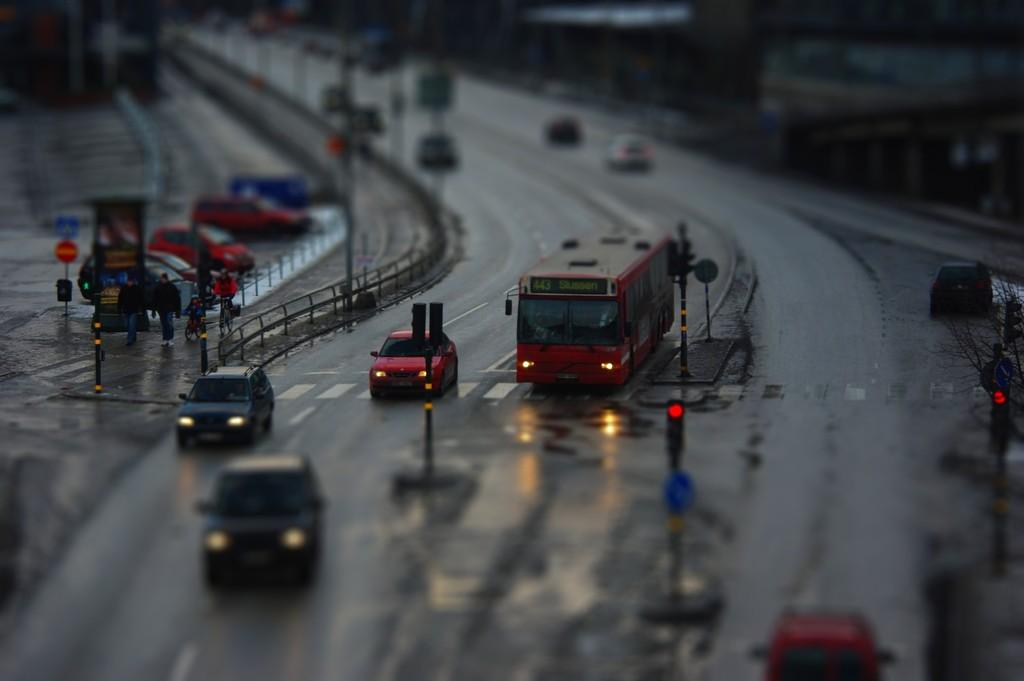What is the overall quality of the image? The image is partially blurred. What can be seen on the road in the image? There are vehicles on the road. What type of barrier surrounds the road? There is fencing around the road. What structures are present near the road? Traffic signal poles are present. What type of vegetation is on the right side of the image? There is a tree on the right side of the image. Can you tell me the color of the snail crawling on the road in the image? There is no snail present in the image; it only features a road with vehicles and other elements. What type of shirt is the traffic signal wearing in the image? There are no people or clothing items present in the image. 